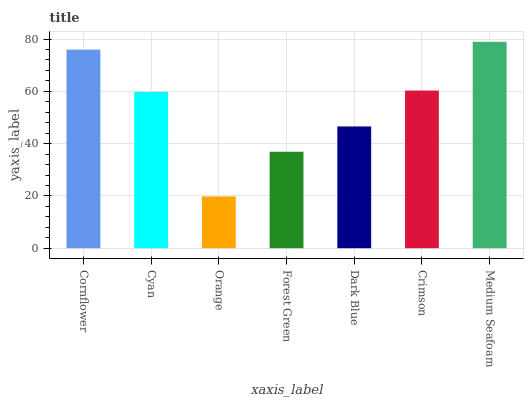Is Cyan the minimum?
Answer yes or no. No. Is Cyan the maximum?
Answer yes or no. No. Is Cornflower greater than Cyan?
Answer yes or no. Yes. Is Cyan less than Cornflower?
Answer yes or no. Yes. Is Cyan greater than Cornflower?
Answer yes or no. No. Is Cornflower less than Cyan?
Answer yes or no. No. Is Cyan the high median?
Answer yes or no. Yes. Is Cyan the low median?
Answer yes or no. Yes. Is Cornflower the high median?
Answer yes or no. No. Is Crimson the low median?
Answer yes or no. No. 